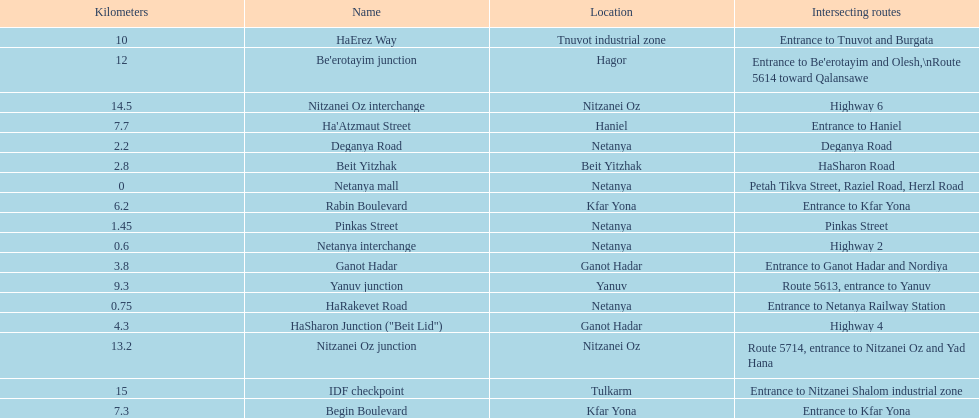Which site is subsequent to kfar yona? Haniel. 